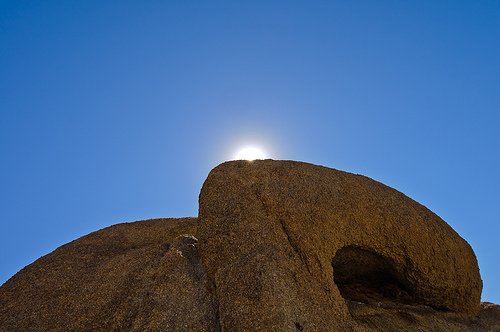<image>
Can you confirm if the cave is under the sun? Yes. The cave is positioned underneath the sun, with the sun above it in the vertical space. 